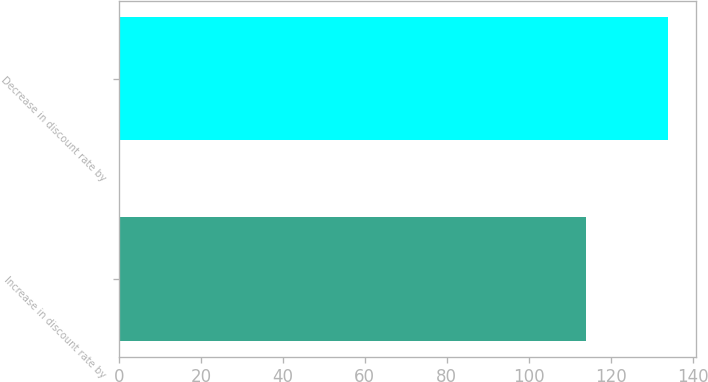Convert chart. <chart><loc_0><loc_0><loc_500><loc_500><bar_chart><fcel>Increase in discount rate by<fcel>Decrease in discount rate by<nl><fcel>114<fcel>134<nl></chart> 